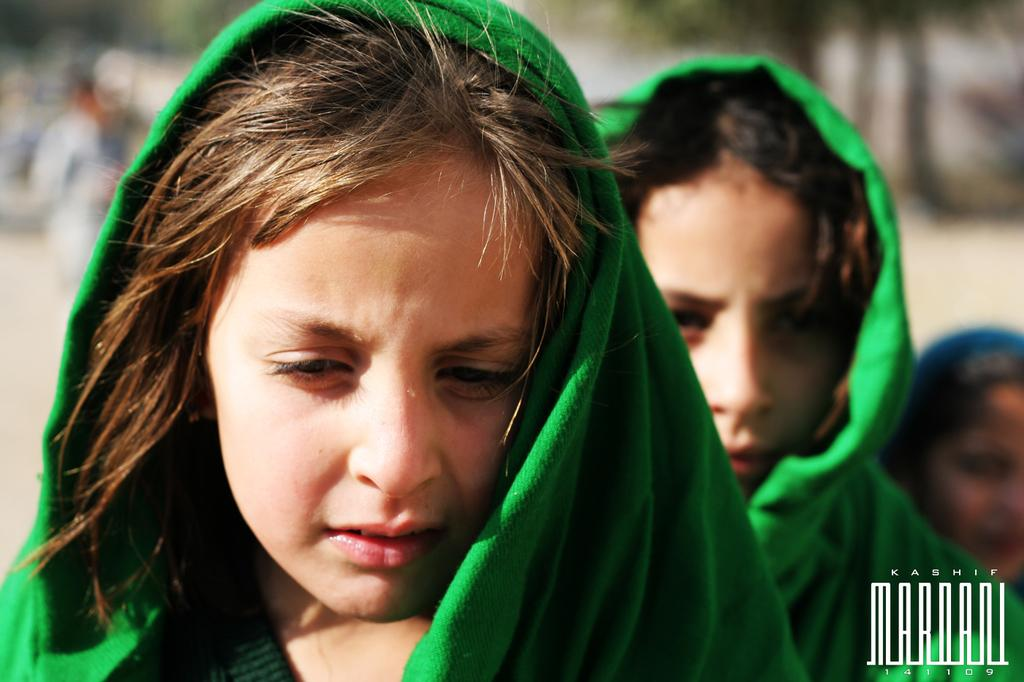How many people are in the image? There are two ladies in the image. What are the ladies wearing around their necks? The ladies are wearing green scarves. Can you describe the background of the image? The background of the image is blurred. Is there any text or symbol in the image? Yes, there is a watermark in the right corner of the image. What type of curtain can be seen in the image? There is no curtain present in the image. What is the view from the window in the image? There is no window or view visible in the image. 